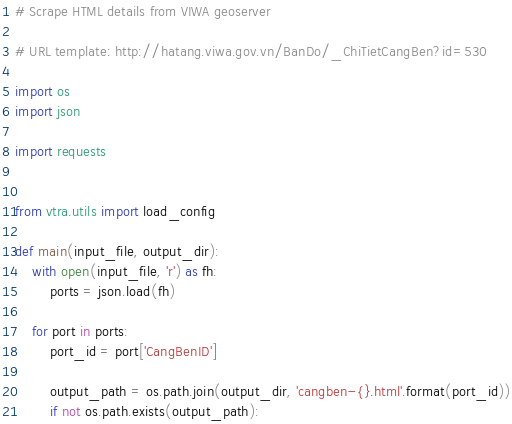<code> <loc_0><loc_0><loc_500><loc_500><_Python_># Scrape HTML details from VIWA geoserver

# URL template: http://hatang.viwa.gov.vn/BanDo/_ChiTietCangBen?id=530

import os
import json

import requests


from vtra.utils import load_config

def main(input_file, output_dir):
	with open(input_file, 'r') as fh:
		ports = json.load(fh)

	for port in ports:
		port_id = port['CangBenID']

		output_path = os.path.join(output_dir, 'cangben-{}.html'.format(port_id))
		if not os.path.exists(output_path):</code> 